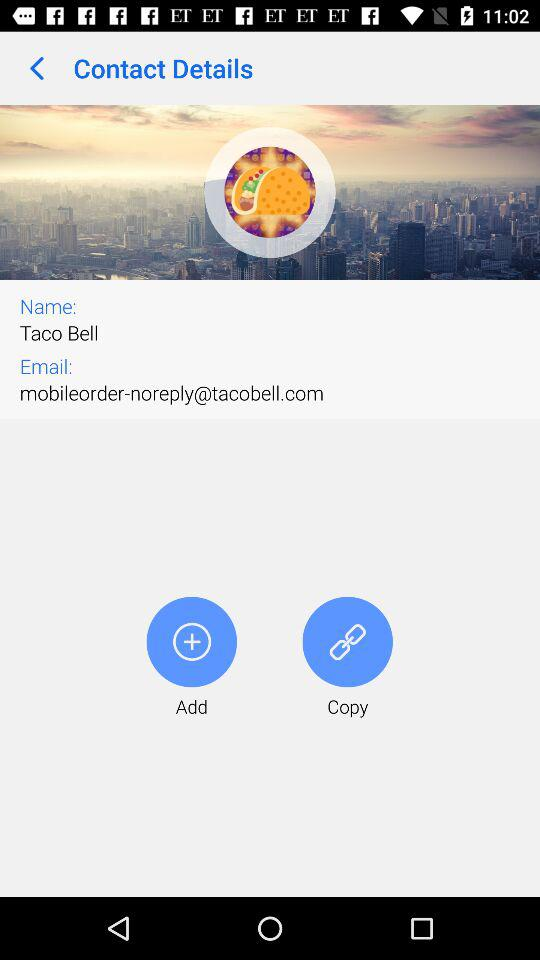What is the name? The name is Taco Bell. 